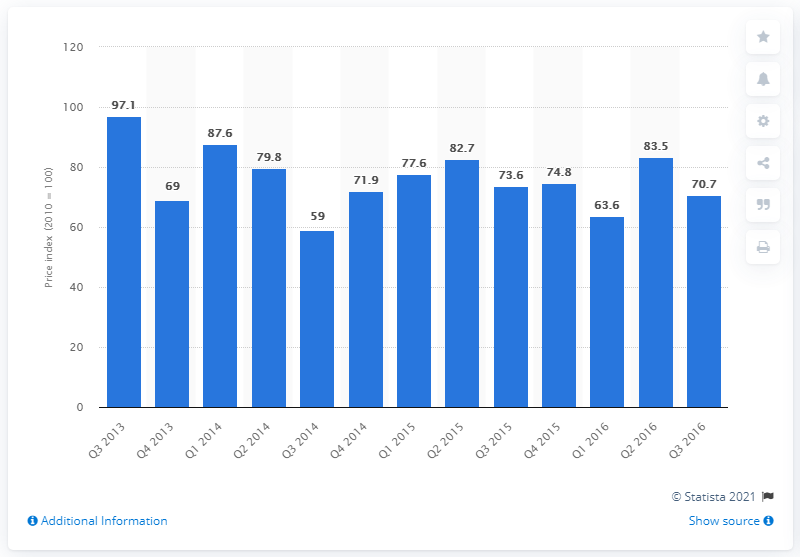Identify some key points in this picture. The building costs index in the Netherlands for the third quarter of 2013 was 70.7. 